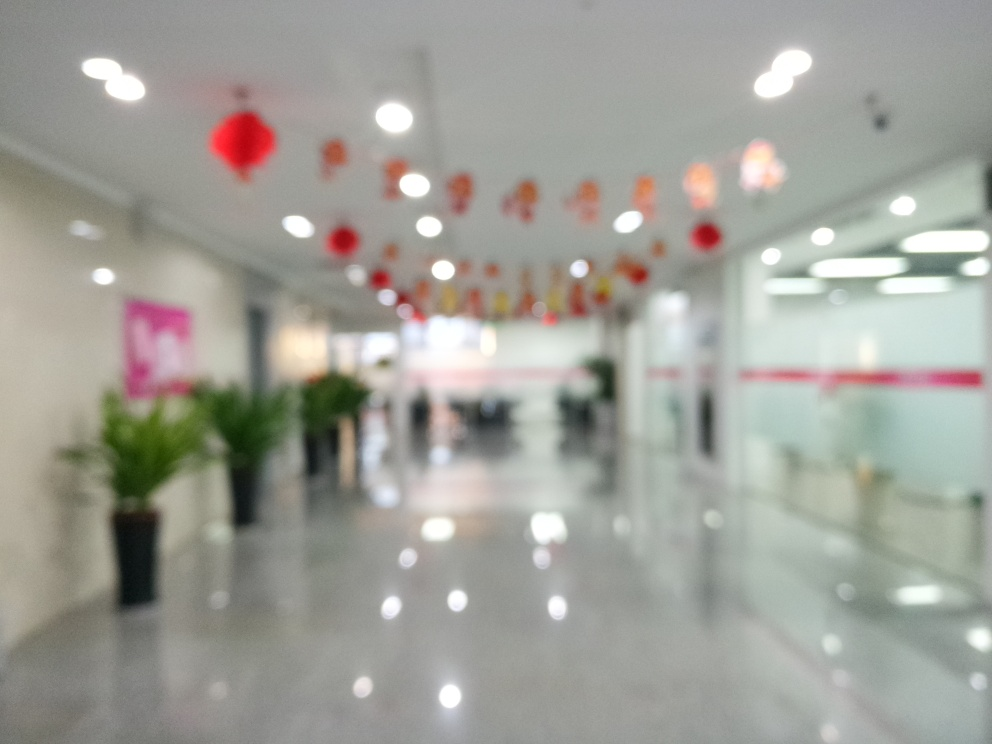How might this image be used effectively? This image could be used effectively in contexts that require a visual emphasis on atmosphere over clarity, such as background imagery for a website, a graphic element in a presentation about perception, or as an example in photography classes to discuss the impact of focus on compositional mood and viewer interpretation. 